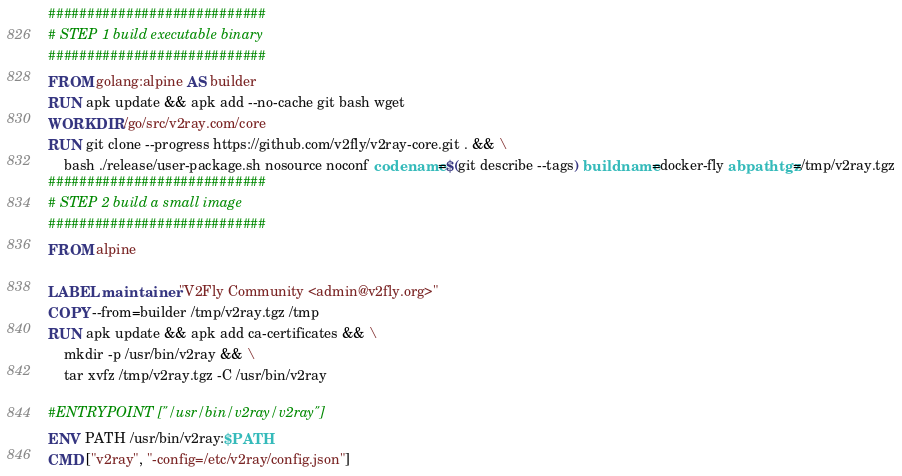Convert code to text. <code><loc_0><loc_0><loc_500><loc_500><_Dockerfile_>############################
# STEP 1 build executable binary
############################
FROM golang:alpine AS builder
RUN apk update && apk add --no-cache git bash wget
WORKDIR /go/src/v2ray.com/core
RUN git clone --progress https://github.com/v2fly/v2ray-core.git . && \
    bash ./release/user-package.sh nosource noconf codename=$(git describe --tags) buildname=docker-fly abpathtgz=/tmp/v2ray.tgz
############################
# STEP 2 build a small image
############################
FROM alpine

LABEL maintainer "V2Fly Community <admin@v2fly.org>"
COPY --from=builder /tmp/v2ray.tgz /tmp
RUN apk update && apk add ca-certificates && \
    mkdir -p /usr/bin/v2ray && \
    tar xvfz /tmp/v2ray.tgz -C /usr/bin/v2ray

#ENTRYPOINT ["/usr/bin/v2ray/v2ray"]
ENV PATH /usr/bin/v2ray:$PATH
CMD ["v2ray", "-config=/etc/v2ray/config.json"]

</code> 